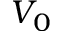Convert formula to latex. <formula><loc_0><loc_0><loc_500><loc_500>V _ { 0 }</formula> 